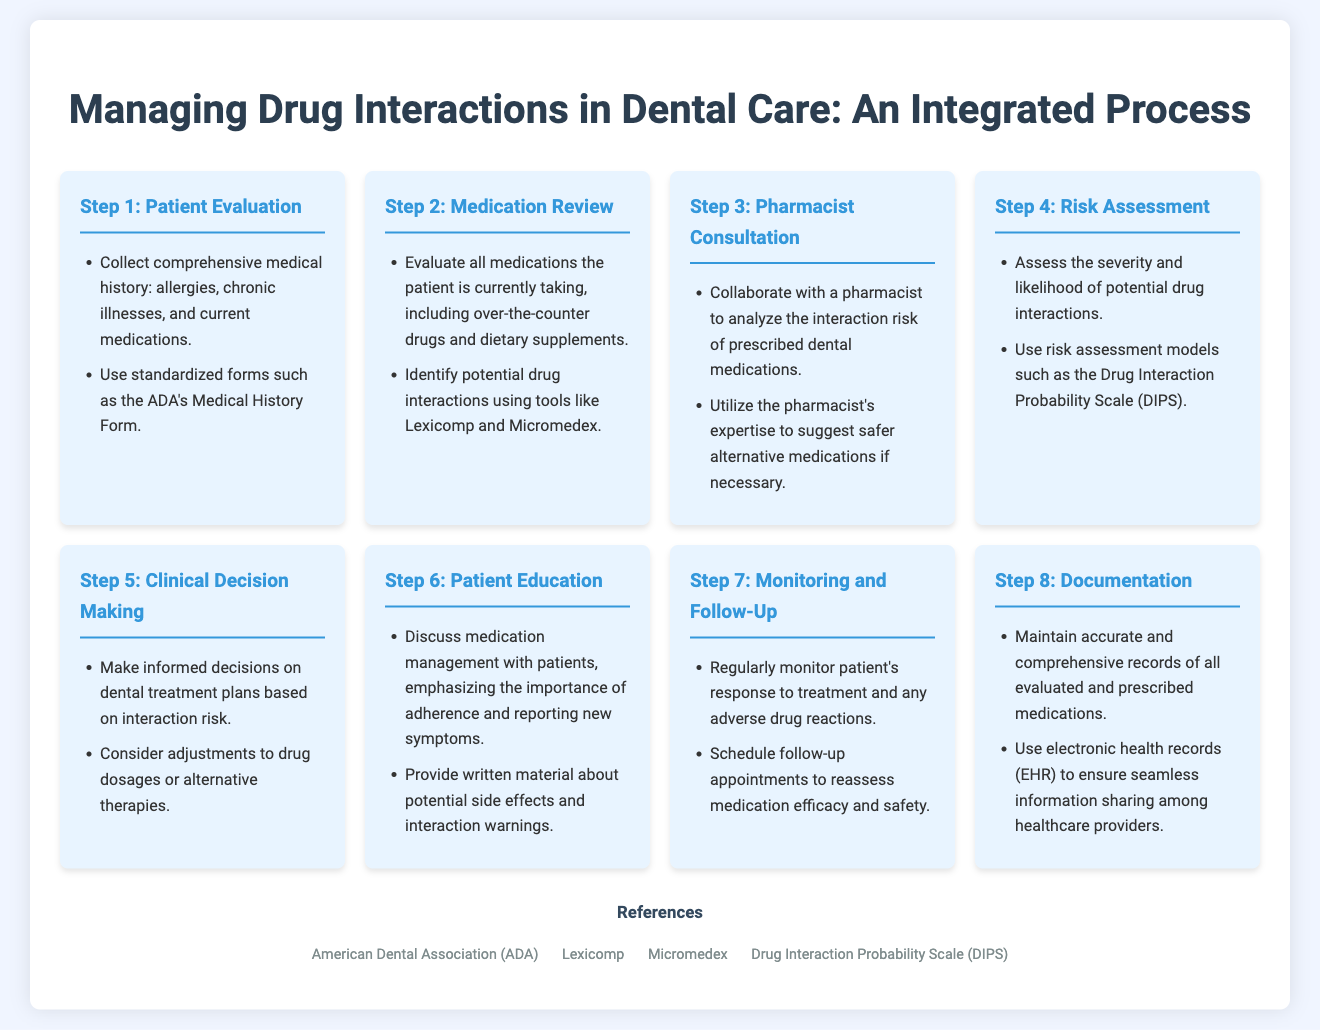What is the first step in the process? The first step in the process is outlined in the document as "Patient Evaluation."
Answer: Patient Evaluation What should be included in the patient's medical history? The document specifies that the patient's medical history should include allergies, chronic illnesses, and current medications.
Answer: Allergies, chronic illnesses, current medications Which tools are recommended for identifying potential drug interactions? The document mentions using "Lexicomp" and "Micromedex" for identifying potential drug interactions.
Answer: Lexicomp and Micromedex What is the purpose of pharmacist consultation in the process? The document states that the pharmacist consultation aims to analyze the interaction risk of prescribed dental medications and to suggest safer alternative medications if necessary.
Answer: Analyze interaction risk and suggest alternatives How many steps are there in the integrated process? By counting the steps listed in the document, there are a total of eight steps in the integrated process.
Answer: Eight What is emphasized during patient education? The document emphasizes discussing medication management, adherence, and reporting new symptoms during patient education.
Answer: Medication management, adherence, and reporting new symptoms What method is mentioned for risk assessment? The document refers to using the "Drug Interaction Probability Scale (DIPS)" for assessing risks.
Answer: Drug Interaction Probability Scale (DIPS) 